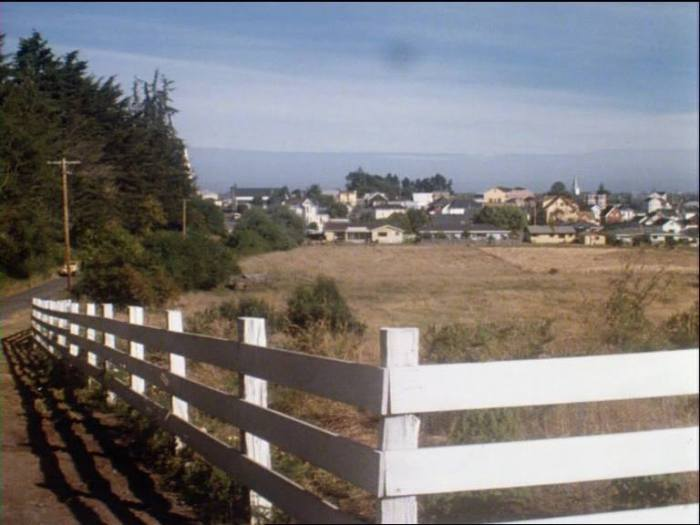If this area were to be developed further, what impact might that have on the local environment? Further development in this area could have both positive and negative impacts on the local environment. On the positive side, careful and sustainable development can enhance local infrastructure, provide more housing, and boost the economy. However, the negative impacts could include habitat loss for native species, pollution (both from construction and increased human activity), and increased pressure on marine ecosystems from potential water contamination or overfishing. Additionally, the natural landscape could become fragmented, disrupting the migratory pathways of animals and reducing biodiversity. Coastal erosion might also be exacerbated by construction activities. To mitigate these impacts, it would be essential to implement green building practices, protect key habitats, and engage in careful land-use planning that prioritizes environmental sustainability. 